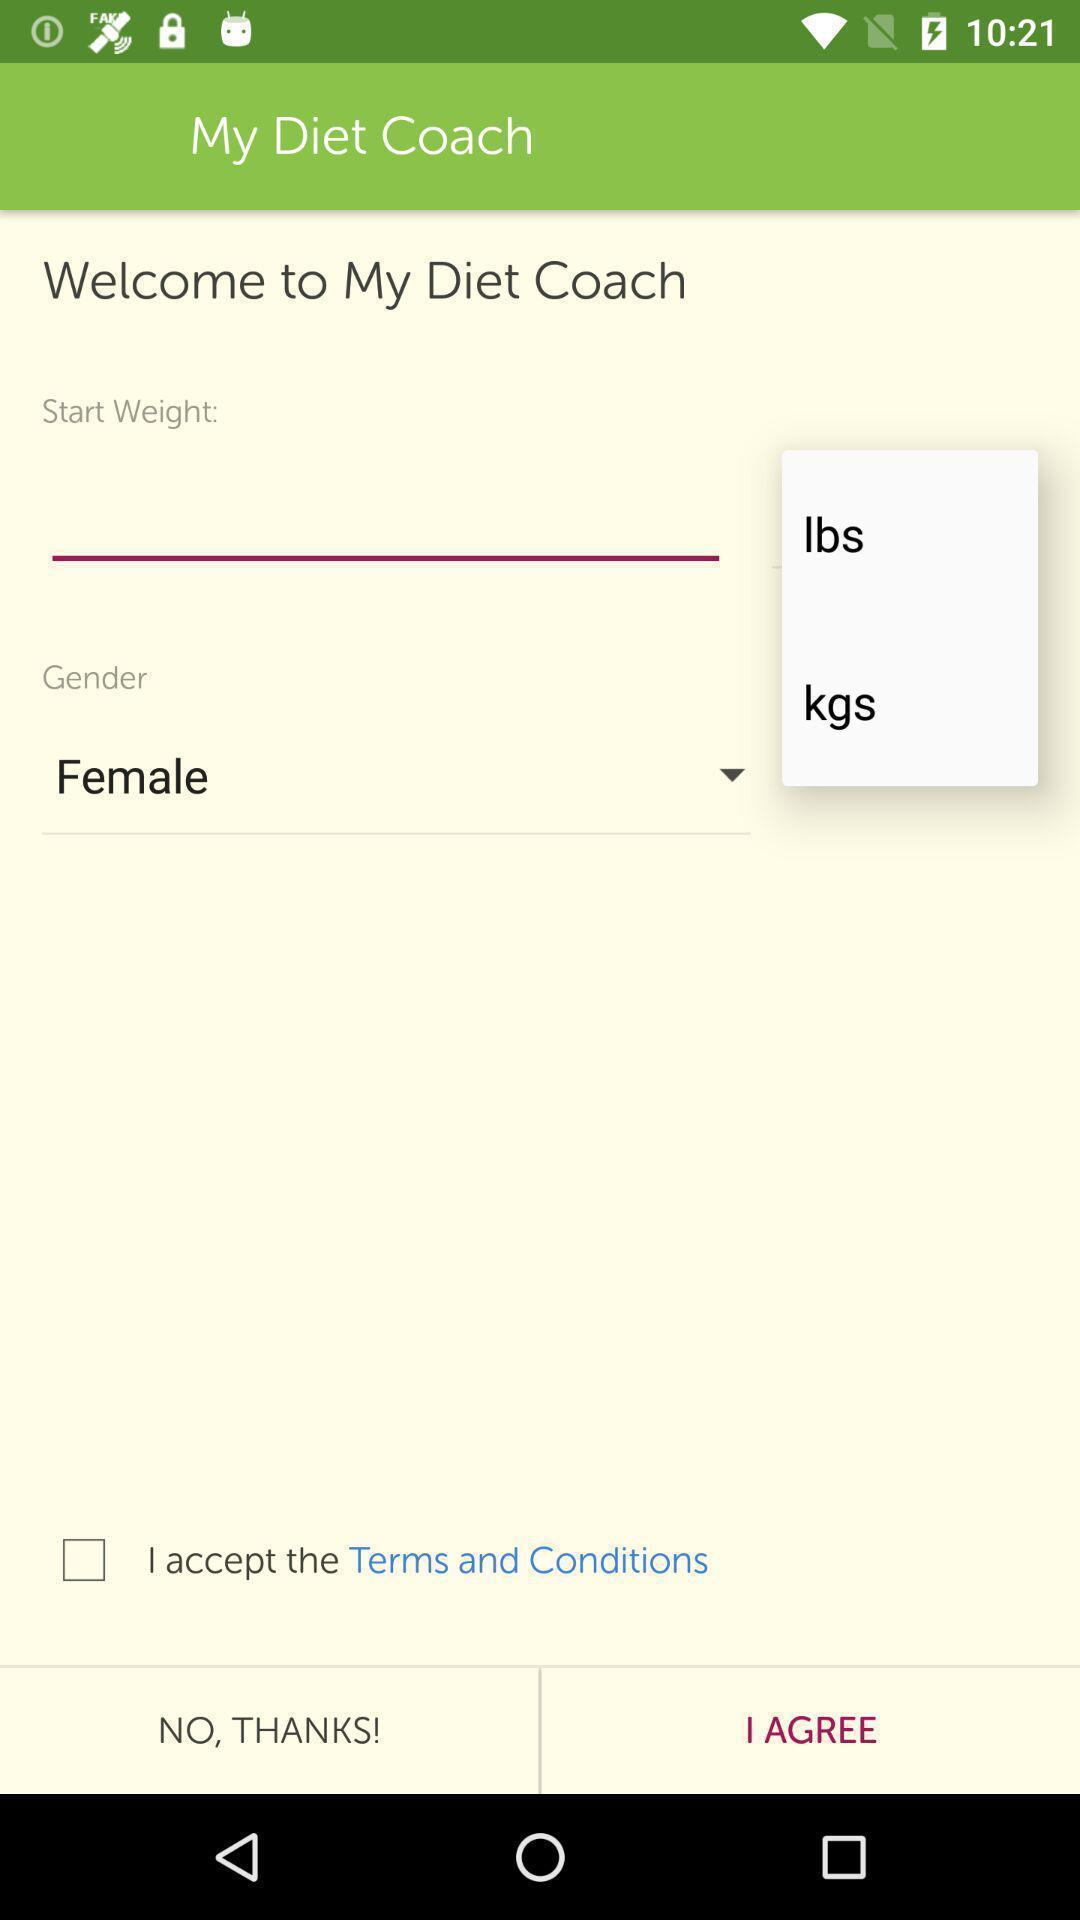What is the overall content of this screenshot? Welcome page of weight tracker application. 